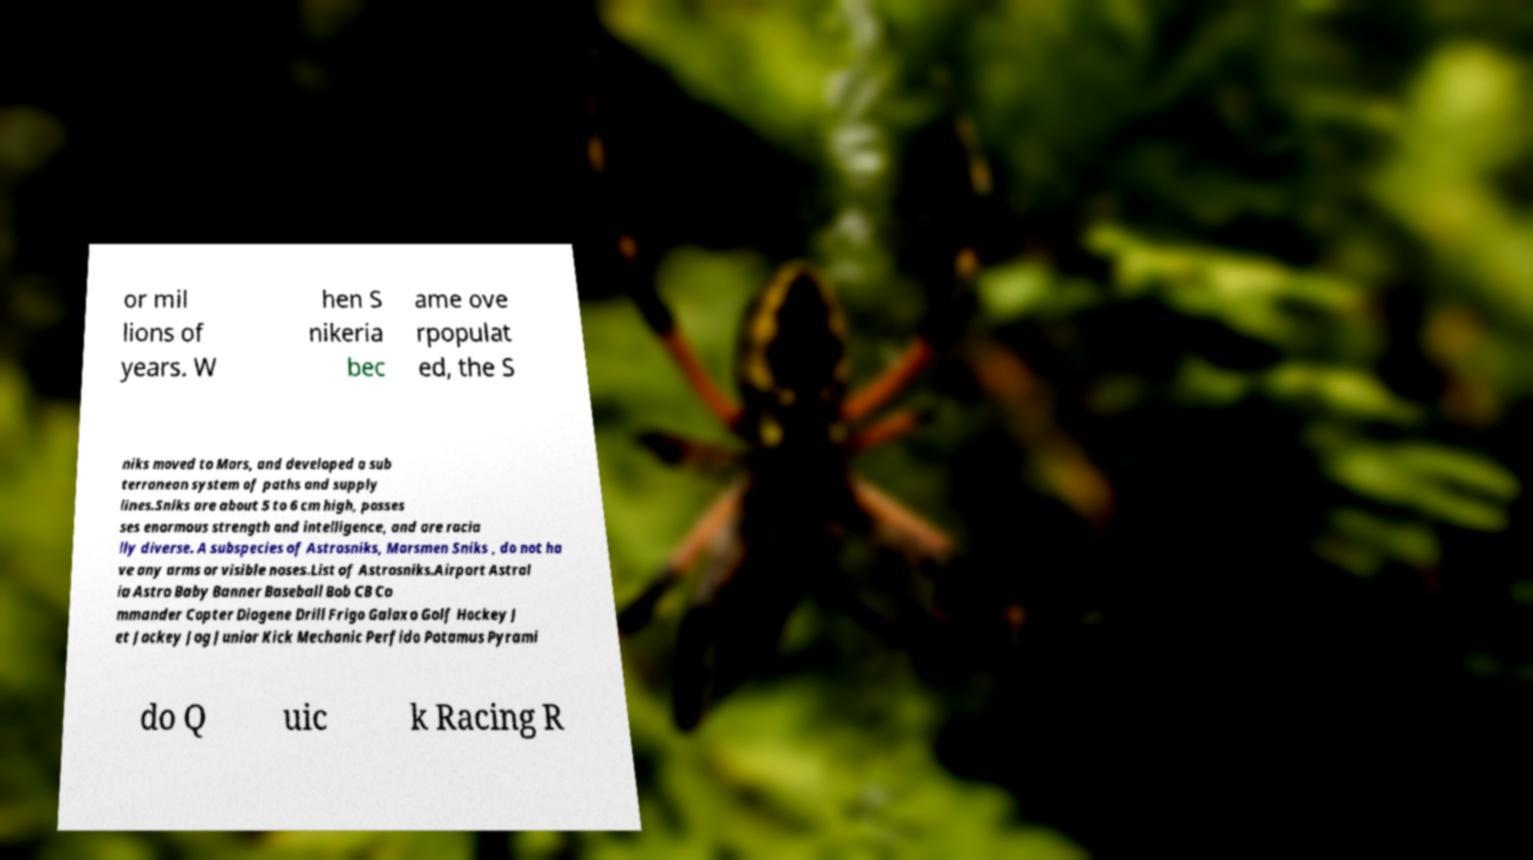Please read and relay the text visible in this image. What does it say? or mil lions of years. W hen S nikeria bec ame ove rpopulat ed, the S niks moved to Mars, and developed a sub terranean system of paths and supply lines.Sniks are about 5 to 6 cm high, posses ses enormous strength and intelligence, and are racia lly diverse. A subspecies of Astrosniks, Marsmen Sniks , do not ha ve any arms or visible noses.List of Astrosniks.Airport Astral ia Astro Baby Banner Baseball Bob CB Co mmander Copter Diogene Drill Frigo Galaxo Golf Hockey J et Jockey Jog Junior Kick Mechanic Perfido Potamus Pyrami do Q uic k Racing R 